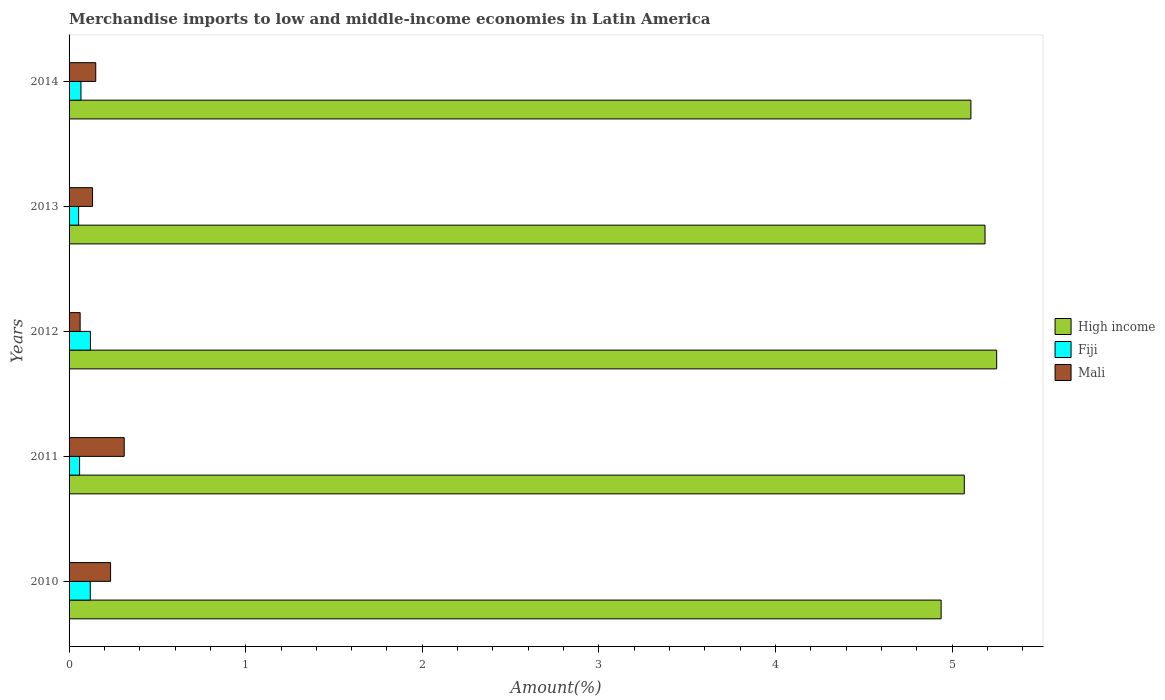How many different coloured bars are there?
Give a very brief answer. 3. How many groups of bars are there?
Provide a short and direct response. 5. Are the number of bars per tick equal to the number of legend labels?
Provide a succinct answer. Yes. How many bars are there on the 5th tick from the top?
Provide a short and direct response. 3. How many bars are there on the 5th tick from the bottom?
Provide a succinct answer. 3. In how many cases, is the number of bars for a given year not equal to the number of legend labels?
Provide a succinct answer. 0. What is the percentage of amount earned from merchandise imports in High income in 2010?
Keep it short and to the point. 4.94. Across all years, what is the maximum percentage of amount earned from merchandise imports in Mali?
Make the answer very short. 0.31. Across all years, what is the minimum percentage of amount earned from merchandise imports in Mali?
Make the answer very short. 0.06. In which year was the percentage of amount earned from merchandise imports in Fiji minimum?
Provide a succinct answer. 2013. What is the total percentage of amount earned from merchandise imports in High income in the graph?
Offer a terse response. 25.55. What is the difference between the percentage of amount earned from merchandise imports in Fiji in 2012 and that in 2013?
Provide a succinct answer. 0.07. What is the difference between the percentage of amount earned from merchandise imports in High income in 2011 and the percentage of amount earned from merchandise imports in Fiji in 2013?
Ensure brevity in your answer.  5.01. What is the average percentage of amount earned from merchandise imports in Fiji per year?
Offer a very short reply. 0.08. In the year 2011, what is the difference between the percentage of amount earned from merchandise imports in Fiji and percentage of amount earned from merchandise imports in Mali?
Provide a succinct answer. -0.25. What is the ratio of the percentage of amount earned from merchandise imports in Fiji in 2012 to that in 2013?
Give a very brief answer. 2.23. What is the difference between the highest and the second highest percentage of amount earned from merchandise imports in High income?
Offer a very short reply. 0.07. What is the difference between the highest and the lowest percentage of amount earned from merchandise imports in Fiji?
Make the answer very short. 0.07. What does the 1st bar from the top in 2014 represents?
Provide a short and direct response. Mali. What does the 3rd bar from the bottom in 2010 represents?
Provide a short and direct response. Mali. Are all the bars in the graph horizontal?
Your response must be concise. Yes. How many years are there in the graph?
Provide a succinct answer. 5. What is the difference between two consecutive major ticks on the X-axis?
Your answer should be compact. 1. Are the values on the major ticks of X-axis written in scientific E-notation?
Make the answer very short. No. Does the graph contain any zero values?
Provide a succinct answer. No. Does the graph contain grids?
Your answer should be very brief. No. Where does the legend appear in the graph?
Make the answer very short. Center right. How many legend labels are there?
Provide a succinct answer. 3. What is the title of the graph?
Your answer should be very brief. Merchandise imports to low and middle-income economies in Latin America. What is the label or title of the X-axis?
Your answer should be very brief. Amount(%). What is the label or title of the Y-axis?
Give a very brief answer. Years. What is the Amount(%) in High income in 2010?
Keep it short and to the point. 4.94. What is the Amount(%) in Fiji in 2010?
Your answer should be compact. 0.12. What is the Amount(%) of Mali in 2010?
Ensure brevity in your answer.  0.23. What is the Amount(%) of High income in 2011?
Offer a very short reply. 5.07. What is the Amount(%) of Fiji in 2011?
Your response must be concise. 0.06. What is the Amount(%) of Mali in 2011?
Give a very brief answer. 0.31. What is the Amount(%) in High income in 2012?
Your answer should be very brief. 5.25. What is the Amount(%) of Fiji in 2012?
Ensure brevity in your answer.  0.12. What is the Amount(%) of Mali in 2012?
Give a very brief answer. 0.06. What is the Amount(%) of High income in 2013?
Keep it short and to the point. 5.19. What is the Amount(%) of Fiji in 2013?
Provide a short and direct response. 0.05. What is the Amount(%) of Mali in 2013?
Offer a terse response. 0.13. What is the Amount(%) of High income in 2014?
Ensure brevity in your answer.  5.11. What is the Amount(%) of Fiji in 2014?
Keep it short and to the point. 0.07. What is the Amount(%) in Mali in 2014?
Give a very brief answer. 0.15. Across all years, what is the maximum Amount(%) of High income?
Your answer should be compact. 5.25. Across all years, what is the maximum Amount(%) in Fiji?
Keep it short and to the point. 0.12. Across all years, what is the maximum Amount(%) in Mali?
Give a very brief answer. 0.31. Across all years, what is the minimum Amount(%) in High income?
Offer a terse response. 4.94. Across all years, what is the minimum Amount(%) in Fiji?
Your answer should be very brief. 0.05. Across all years, what is the minimum Amount(%) in Mali?
Make the answer very short. 0.06. What is the total Amount(%) in High income in the graph?
Ensure brevity in your answer.  25.55. What is the total Amount(%) in Fiji in the graph?
Provide a short and direct response. 0.42. What is the total Amount(%) of Mali in the graph?
Offer a very short reply. 0.89. What is the difference between the Amount(%) in High income in 2010 and that in 2011?
Your answer should be compact. -0.13. What is the difference between the Amount(%) in Fiji in 2010 and that in 2011?
Your answer should be very brief. 0.06. What is the difference between the Amount(%) in Mali in 2010 and that in 2011?
Ensure brevity in your answer.  -0.08. What is the difference between the Amount(%) in High income in 2010 and that in 2012?
Provide a succinct answer. -0.31. What is the difference between the Amount(%) in Fiji in 2010 and that in 2012?
Your response must be concise. -0. What is the difference between the Amount(%) in Mali in 2010 and that in 2012?
Ensure brevity in your answer.  0.17. What is the difference between the Amount(%) of High income in 2010 and that in 2013?
Ensure brevity in your answer.  -0.25. What is the difference between the Amount(%) of Fiji in 2010 and that in 2013?
Offer a terse response. 0.07. What is the difference between the Amount(%) of Mali in 2010 and that in 2013?
Provide a succinct answer. 0.1. What is the difference between the Amount(%) in High income in 2010 and that in 2014?
Your answer should be compact. -0.17. What is the difference between the Amount(%) in Fiji in 2010 and that in 2014?
Offer a terse response. 0.05. What is the difference between the Amount(%) in Mali in 2010 and that in 2014?
Make the answer very short. 0.08. What is the difference between the Amount(%) of High income in 2011 and that in 2012?
Your response must be concise. -0.18. What is the difference between the Amount(%) of Fiji in 2011 and that in 2012?
Provide a succinct answer. -0.06. What is the difference between the Amount(%) of Mali in 2011 and that in 2012?
Make the answer very short. 0.25. What is the difference between the Amount(%) of High income in 2011 and that in 2013?
Your response must be concise. -0.12. What is the difference between the Amount(%) of Fiji in 2011 and that in 2013?
Your answer should be very brief. 0.01. What is the difference between the Amount(%) of Mali in 2011 and that in 2013?
Offer a very short reply. 0.18. What is the difference between the Amount(%) in High income in 2011 and that in 2014?
Your response must be concise. -0.04. What is the difference between the Amount(%) in Fiji in 2011 and that in 2014?
Offer a very short reply. -0.01. What is the difference between the Amount(%) in Mali in 2011 and that in 2014?
Your answer should be very brief. 0.16. What is the difference between the Amount(%) of High income in 2012 and that in 2013?
Your answer should be compact. 0.07. What is the difference between the Amount(%) of Fiji in 2012 and that in 2013?
Provide a succinct answer. 0.07. What is the difference between the Amount(%) in Mali in 2012 and that in 2013?
Make the answer very short. -0.07. What is the difference between the Amount(%) of High income in 2012 and that in 2014?
Your answer should be compact. 0.15. What is the difference between the Amount(%) of Fiji in 2012 and that in 2014?
Keep it short and to the point. 0.05. What is the difference between the Amount(%) in Mali in 2012 and that in 2014?
Keep it short and to the point. -0.09. What is the difference between the Amount(%) in High income in 2013 and that in 2014?
Offer a terse response. 0.08. What is the difference between the Amount(%) in Fiji in 2013 and that in 2014?
Your response must be concise. -0.01. What is the difference between the Amount(%) in Mali in 2013 and that in 2014?
Your answer should be very brief. -0.02. What is the difference between the Amount(%) of High income in 2010 and the Amount(%) of Fiji in 2011?
Your answer should be very brief. 4.88. What is the difference between the Amount(%) of High income in 2010 and the Amount(%) of Mali in 2011?
Make the answer very short. 4.63. What is the difference between the Amount(%) of Fiji in 2010 and the Amount(%) of Mali in 2011?
Provide a succinct answer. -0.19. What is the difference between the Amount(%) of High income in 2010 and the Amount(%) of Fiji in 2012?
Make the answer very short. 4.82. What is the difference between the Amount(%) in High income in 2010 and the Amount(%) in Mali in 2012?
Provide a short and direct response. 4.88. What is the difference between the Amount(%) of Fiji in 2010 and the Amount(%) of Mali in 2012?
Make the answer very short. 0.06. What is the difference between the Amount(%) of High income in 2010 and the Amount(%) of Fiji in 2013?
Make the answer very short. 4.88. What is the difference between the Amount(%) in High income in 2010 and the Amount(%) in Mali in 2013?
Offer a terse response. 4.8. What is the difference between the Amount(%) in Fiji in 2010 and the Amount(%) in Mali in 2013?
Give a very brief answer. -0.01. What is the difference between the Amount(%) in High income in 2010 and the Amount(%) in Fiji in 2014?
Keep it short and to the point. 4.87. What is the difference between the Amount(%) in High income in 2010 and the Amount(%) in Mali in 2014?
Keep it short and to the point. 4.79. What is the difference between the Amount(%) of Fiji in 2010 and the Amount(%) of Mali in 2014?
Ensure brevity in your answer.  -0.03. What is the difference between the Amount(%) of High income in 2011 and the Amount(%) of Fiji in 2012?
Give a very brief answer. 4.95. What is the difference between the Amount(%) in High income in 2011 and the Amount(%) in Mali in 2012?
Make the answer very short. 5.01. What is the difference between the Amount(%) of Fiji in 2011 and the Amount(%) of Mali in 2012?
Offer a terse response. -0. What is the difference between the Amount(%) in High income in 2011 and the Amount(%) in Fiji in 2013?
Keep it short and to the point. 5.01. What is the difference between the Amount(%) of High income in 2011 and the Amount(%) of Mali in 2013?
Give a very brief answer. 4.94. What is the difference between the Amount(%) of Fiji in 2011 and the Amount(%) of Mali in 2013?
Give a very brief answer. -0.07. What is the difference between the Amount(%) of High income in 2011 and the Amount(%) of Fiji in 2014?
Ensure brevity in your answer.  5. What is the difference between the Amount(%) in High income in 2011 and the Amount(%) in Mali in 2014?
Offer a terse response. 4.92. What is the difference between the Amount(%) in Fiji in 2011 and the Amount(%) in Mali in 2014?
Provide a short and direct response. -0.09. What is the difference between the Amount(%) in High income in 2012 and the Amount(%) in Fiji in 2013?
Keep it short and to the point. 5.2. What is the difference between the Amount(%) of High income in 2012 and the Amount(%) of Mali in 2013?
Ensure brevity in your answer.  5.12. What is the difference between the Amount(%) of Fiji in 2012 and the Amount(%) of Mali in 2013?
Keep it short and to the point. -0.01. What is the difference between the Amount(%) of High income in 2012 and the Amount(%) of Fiji in 2014?
Your response must be concise. 5.19. What is the difference between the Amount(%) of High income in 2012 and the Amount(%) of Mali in 2014?
Make the answer very short. 5.1. What is the difference between the Amount(%) of Fiji in 2012 and the Amount(%) of Mali in 2014?
Offer a very short reply. -0.03. What is the difference between the Amount(%) of High income in 2013 and the Amount(%) of Fiji in 2014?
Offer a very short reply. 5.12. What is the difference between the Amount(%) of High income in 2013 and the Amount(%) of Mali in 2014?
Ensure brevity in your answer.  5.04. What is the difference between the Amount(%) of Fiji in 2013 and the Amount(%) of Mali in 2014?
Give a very brief answer. -0.1. What is the average Amount(%) in High income per year?
Ensure brevity in your answer.  5.11. What is the average Amount(%) of Fiji per year?
Offer a terse response. 0.08. What is the average Amount(%) of Mali per year?
Make the answer very short. 0.18. In the year 2010, what is the difference between the Amount(%) in High income and Amount(%) in Fiji?
Ensure brevity in your answer.  4.82. In the year 2010, what is the difference between the Amount(%) in High income and Amount(%) in Mali?
Make the answer very short. 4.7. In the year 2010, what is the difference between the Amount(%) of Fiji and Amount(%) of Mali?
Provide a short and direct response. -0.11. In the year 2011, what is the difference between the Amount(%) in High income and Amount(%) in Fiji?
Keep it short and to the point. 5.01. In the year 2011, what is the difference between the Amount(%) in High income and Amount(%) in Mali?
Your answer should be very brief. 4.76. In the year 2011, what is the difference between the Amount(%) of Fiji and Amount(%) of Mali?
Offer a very short reply. -0.25. In the year 2012, what is the difference between the Amount(%) in High income and Amount(%) in Fiji?
Provide a short and direct response. 5.13. In the year 2012, what is the difference between the Amount(%) of High income and Amount(%) of Mali?
Ensure brevity in your answer.  5.19. In the year 2012, what is the difference between the Amount(%) in Fiji and Amount(%) in Mali?
Your answer should be compact. 0.06. In the year 2013, what is the difference between the Amount(%) in High income and Amount(%) in Fiji?
Your response must be concise. 5.13. In the year 2013, what is the difference between the Amount(%) in High income and Amount(%) in Mali?
Give a very brief answer. 5.05. In the year 2013, what is the difference between the Amount(%) of Fiji and Amount(%) of Mali?
Make the answer very short. -0.08. In the year 2014, what is the difference between the Amount(%) in High income and Amount(%) in Fiji?
Make the answer very short. 5.04. In the year 2014, what is the difference between the Amount(%) of High income and Amount(%) of Mali?
Make the answer very short. 4.96. In the year 2014, what is the difference between the Amount(%) of Fiji and Amount(%) of Mali?
Give a very brief answer. -0.08. What is the ratio of the Amount(%) of High income in 2010 to that in 2011?
Your response must be concise. 0.97. What is the ratio of the Amount(%) of Fiji in 2010 to that in 2011?
Keep it short and to the point. 2.02. What is the ratio of the Amount(%) in Mali in 2010 to that in 2011?
Offer a terse response. 0.75. What is the ratio of the Amount(%) of High income in 2010 to that in 2012?
Your answer should be very brief. 0.94. What is the ratio of the Amount(%) in Fiji in 2010 to that in 2012?
Offer a very short reply. 0.99. What is the ratio of the Amount(%) in Mali in 2010 to that in 2012?
Your answer should be very brief. 3.75. What is the ratio of the Amount(%) in High income in 2010 to that in 2013?
Your answer should be compact. 0.95. What is the ratio of the Amount(%) of Fiji in 2010 to that in 2013?
Offer a terse response. 2.22. What is the ratio of the Amount(%) in Mali in 2010 to that in 2013?
Keep it short and to the point. 1.77. What is the ratio of the Amount(%) in High income in 2010 to that in 2014?
Your response must be concise. 0.97. What is the ratio of the Amount(%) in Fiji in 2010 to that in 2014?
Provide a succinct answer. 1.79. What is the ratio of the Amount(%) of Mali in 2010 to that in 2014?
Your response must be concise. 1.56. What is the ratio of the Amount(%) of High income in 2011 to that in 2012?
Your answer should be very brief. 0.97. What is the ratio of the Amount(%) in Fiji in 2011 to that in 2012?
Provide a short and direct response. 0.49. What is the ratio of the Amount(%) of Mali in 2011 to that in 2012?
Offer a terse response. 4.98. What is the ratio of the Amount(%) of High income in 2011 to that in 2013?
Provide a succinct answer. 0.98. What is the ratio of the Amount(%) in Fiji in 2011 to that in 2013?
Provide a succinct answer. 1.1. What is the ratio of the Amount(%) of Mali in 2011 to that in 2013?
Keep it short and to the point. 2.35. What is the ratio of the Amount(%) in High income in 2011 to that in 2014?
Give a very brief answer. 0.99. What is the ratio of the Amount(%) in Fiji in 2011 to that in 2014?
Offer a very short reply. 0.89. What is the ratio of the Amount(%) of Mali in 2011 to that in 2014?
Offer a terse response. 2.07. What is the ratio of the Amount(%) of High income in 2012 to that in 2013?
Make the answer very short. 1.01. What is the ratio of the Amount(%) of Fiji in 2012 to that in 2013?
Give a very brief answer. 2.23. What is the ratio of the Amount(%) in Mali in 2012 to that in 2013?
Offer a very short reply. 0.47. What is the ratio of the Amount(%) in High income in 2012 to that in 2014?
Provide a succinct answer. 1.03. What is the ratio of the Amount(%) in Fiji in 2012 to that in 2014?
Give a very brief answer. 1.8. What is the ratio of the Amount(%) in Mali in 2012 to that in 2014?
Your answer should be compact. 0.41. What is the ratio of the Amount(%) of High income in 2013 to that in 2014?
Give a very brief answer. 1.02. What is the ratio of the Amount(%) of Fiji in 2013 to that in 2014?
Give a very brief answer. 0.81. What is the ratio of the Amount(%) of Mali in 2013 to that in 2014?
Your answer should be very brief. 0.88. What is the difference between the highest and the second highest Amount(%) of High income?
Keep it short and to the point. 0.07. What is the difference between the highest and the second highest Amount(%) in Fiji?
Offer a very short reply. 0. What is the difference between the highest and the second highest Amount(%) of Mali?
Give a very brief answer. 0.08. What is the difference between the highest and the lowest Amount(%) of High income?
Make the answer very short. 0.31. What is the difference between the highest and the lowest Amount(%) in Fiji?
Make the answer very short. 0.07. What is the difference between the highest and the lowest Amount(%) in Mali?
Provide a short and direct response. 0.25. 